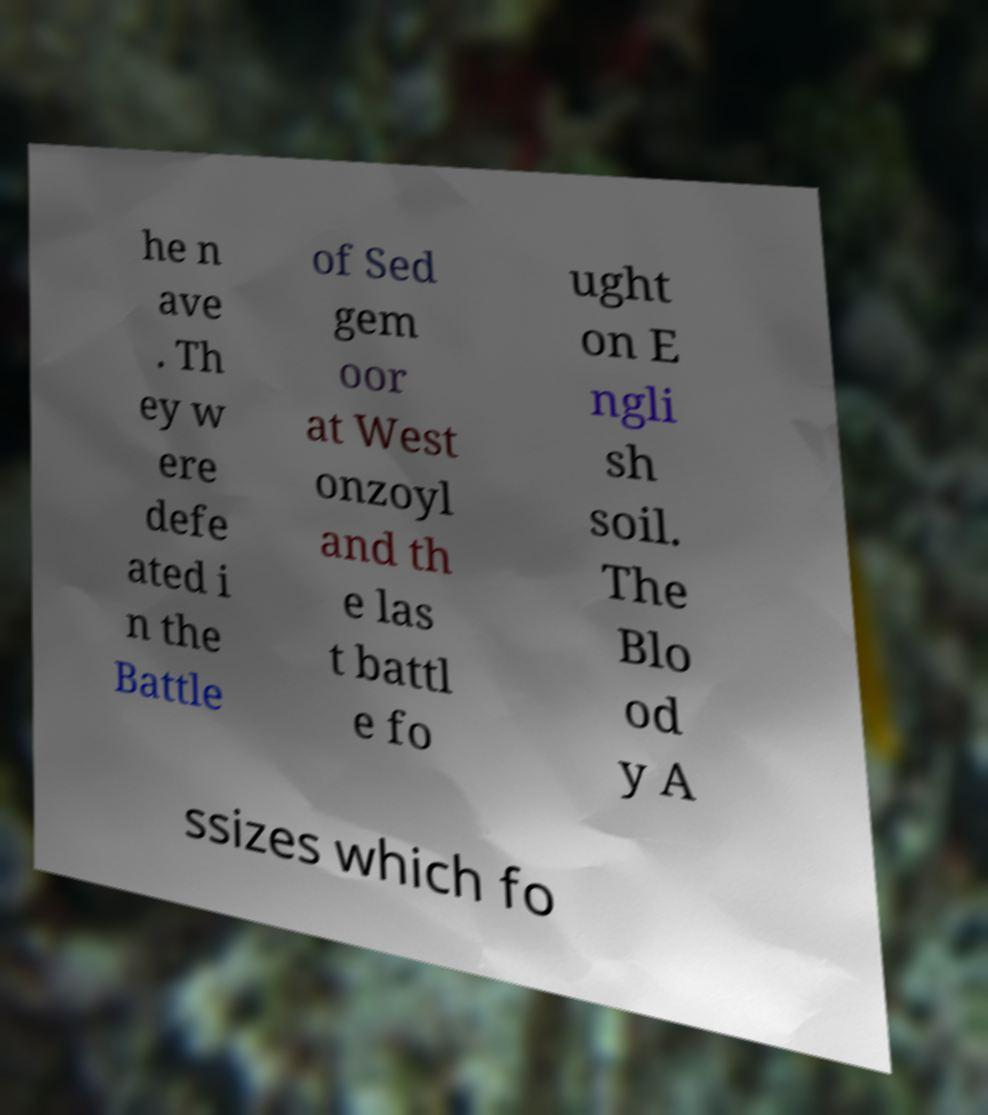Can you read and provide the text displayed in the image?This photo seems to have some interesting text. Can you extract and type it out for me? he n ave . Th ey w ere defe ated i n the Battle of Sed gem oor at West onzoyl and th e las t battl e fo ught on E ngli sh soil. The Blo od y A ssizes which fo 